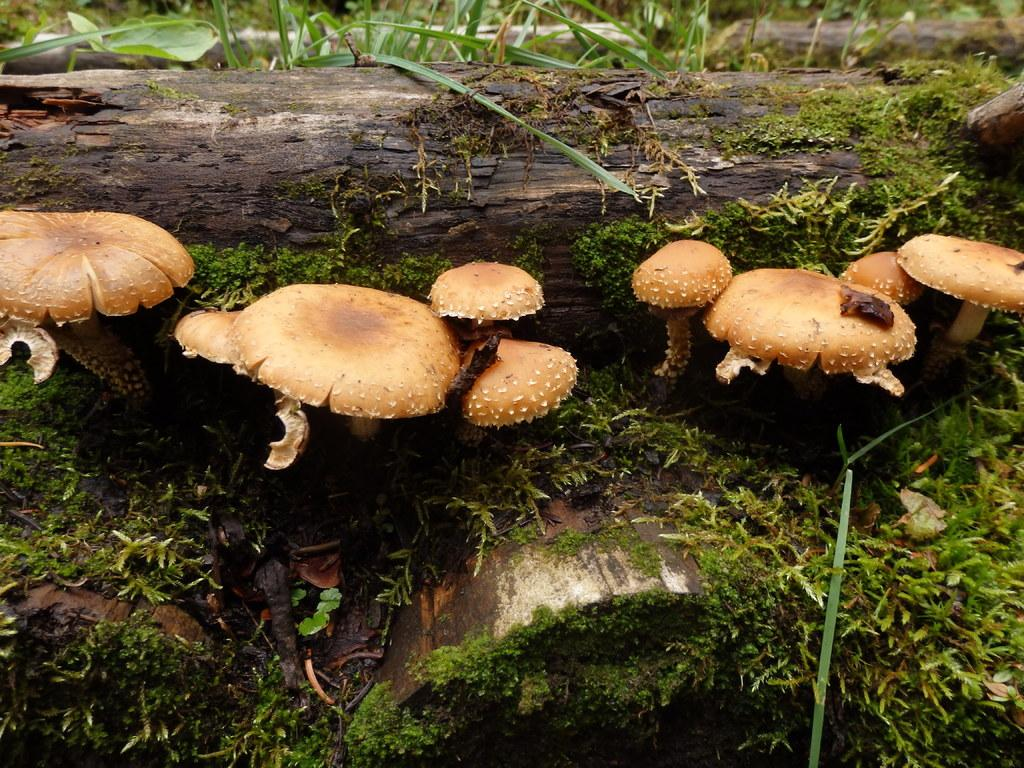What type of fungi can be seen in the image? There are mushrooms in the image. What other types of vegetation are present in the image? There are plants in the image. What material is visible in the image? There is wood in the image. What type of growth can be seen on the wood in the image? There is green algae in the image. How does the mint plant contribute to the image? There is no mint plant present in the image. 